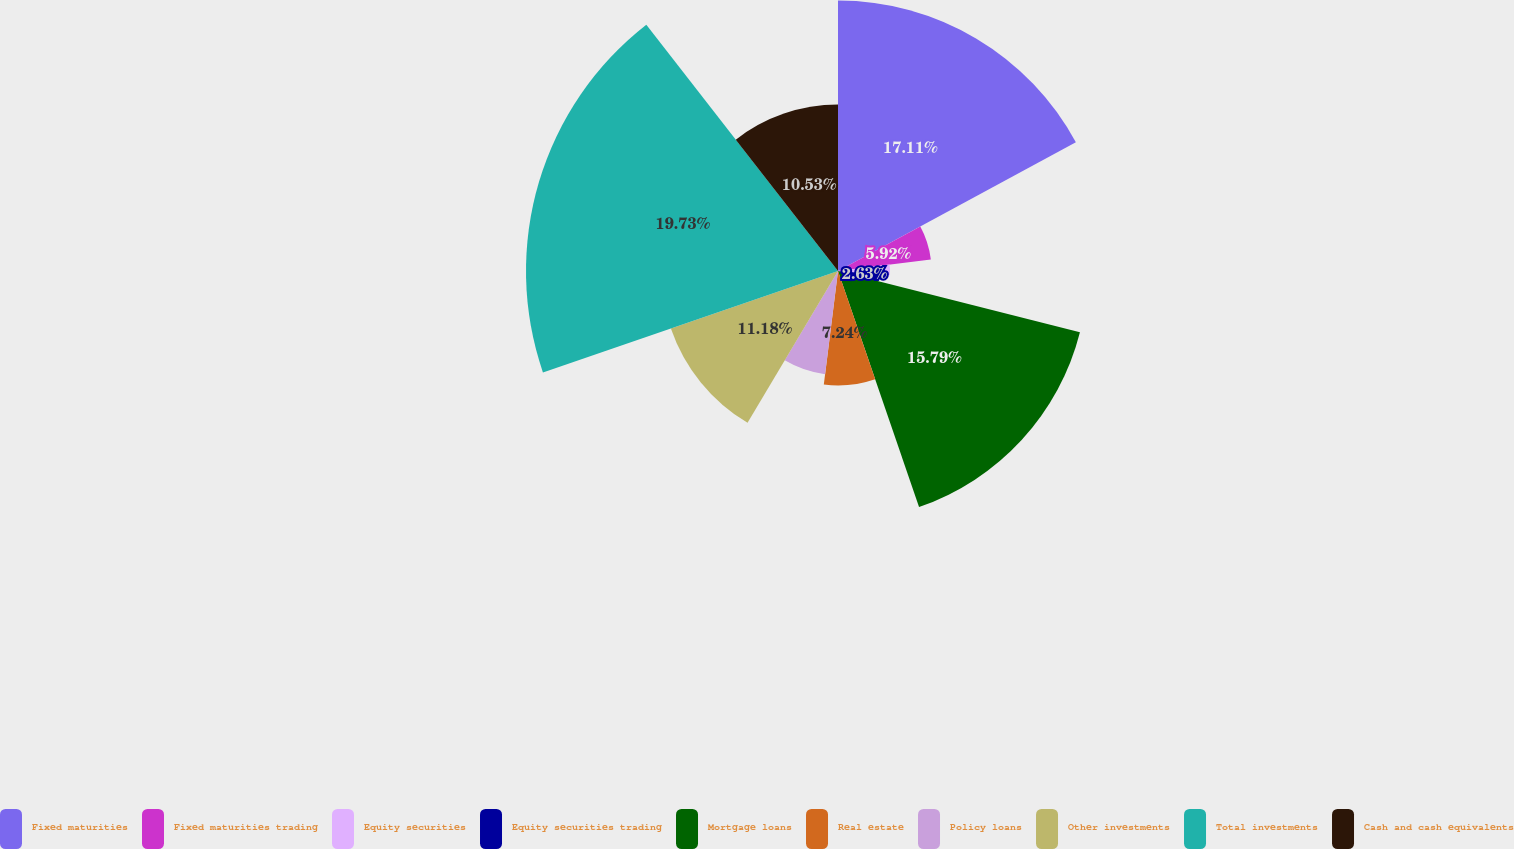Convert chart to OTSL. <chart><loc_0><loc_0><loc_500><loc_500><pie_chart><fcel>Fixed maturities<fcel>Fixed maturities trading<fcel>Equity securities<fcel>Equity securities trading<fcel>Mortgage loans<fcel>Real estate<fcel>Policy loans<fcel>Other investments<fcel>Total investments<fcel>Cash and cash equivalents<nl><fcel>17.11%<fcel>5.92%<fcel>3.29%<fcel>2.63%<fcel>15.79%<fcel>7.24%<fcel>6.58%<fcel>11.18%<fcel>19.74%<fcel>10.53%<nl></chart> 